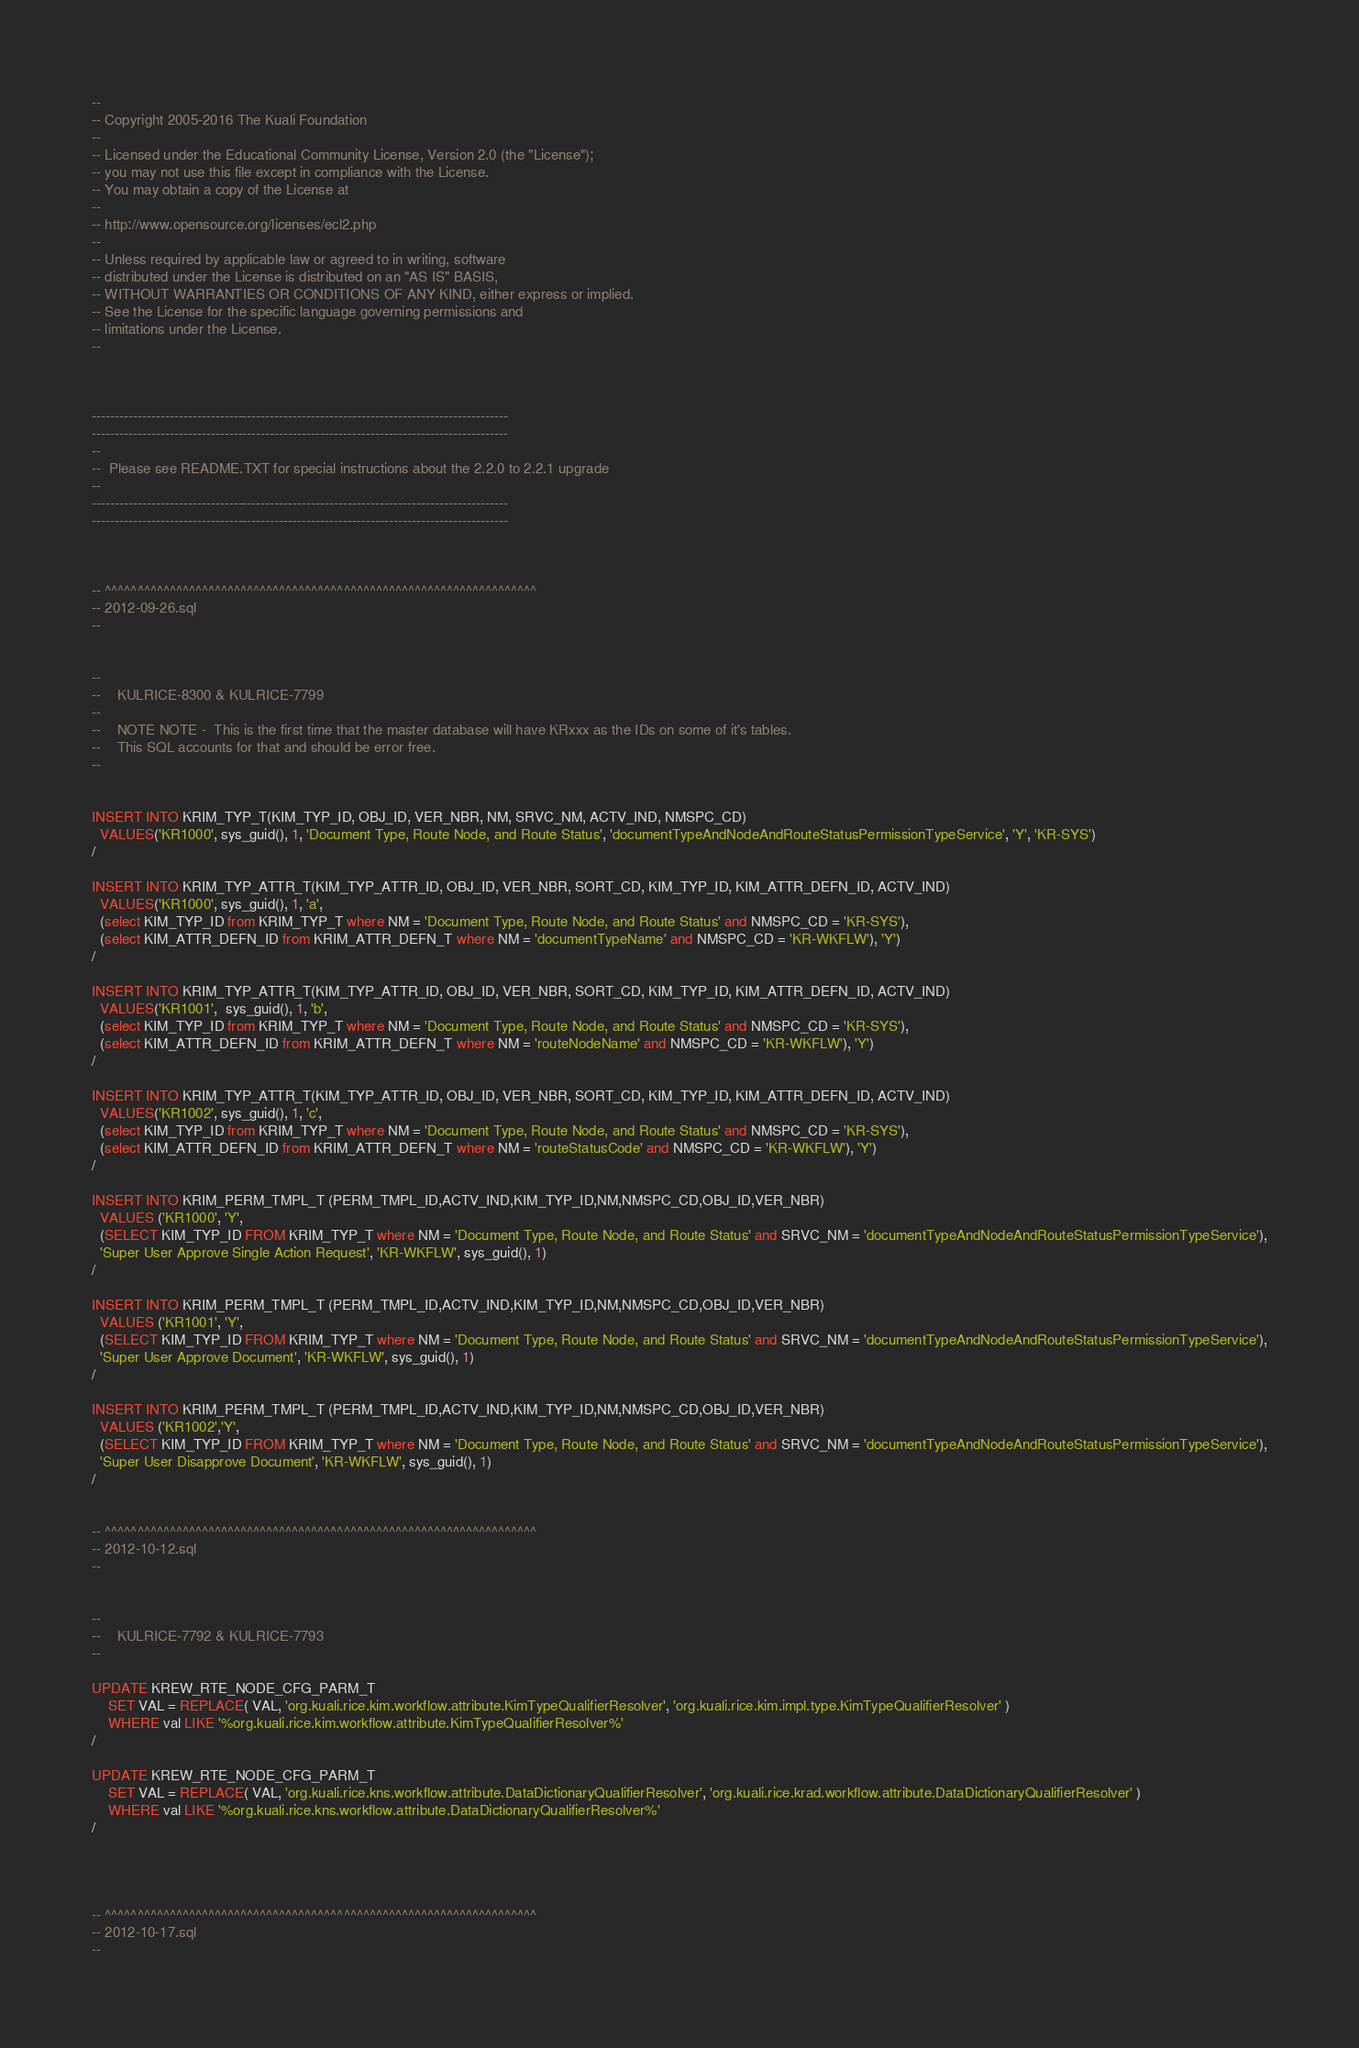<code> <loc_0><loc_0><loc_500><loc_500><_SQL_>--
-- Copyright 2005-2016 The Kuali Foundation
--
-- Licensed under the Educational Community License, Version 2.0 (the "License");
-- you may not use this file except in compliance with the License.
-- You may obtain a copy of the License at
--
-- http://www.opensource.org/licenses/ecl2.php
--
-- Unless required by applicable law or agreed to in writing, software
-- distributed under the License is distributed on an "AS IS" BASIS,
-- WITHOUT WARRANTIES OR CONDITIONS OF ANY KIND, either express or implied.
-- See the License for the specific language governing permissions and
-- limitations under the License.
--



-------------------------------------------------------------------------------------------
-------------------------------------------------------------------------------------------
--
--  Please see README.TXT for special instructions about the 2.2.0 to 2.2.1 upgrade
--
-------------------------------------------------------------------------------------------
-------------------------------------------------------------------------------------------



-- ^^^^^^^^^^^^^^^^^^^^^^^^^^^^^^^^^^^^^^^^^^^^^^^^^^^^^^^^^^^^^^^^^^^
-- 2012-09-26.sql
--


--
--    KULRICE-8300 & KULRICE-7799
--
--    NOTE NOTE -  This is the first time that the master database will have KRxxx as the IDs on some of it's tables.
--    This SQL accounts for that and should be error free.
--


INSERT INTO KRIM_TYP_T(KIM_TYP_ID, OBJ_ID, VER_NBR, NM, SRVC_NM, ACTV_IND, NMSPC_CD)
  VALUES('KR1000', sys_guid(), 1, 'Document Type, Route Node, and Route Status', 'documentTypeAndNodeAndRouteStatusPermissionTypeService', 'Y', 'KR-SYS')
/

INSERT INTO KRIM_TYP_ATTR_T(KIM_TYP_ATTR_ID, OBJ_ID, VER_NBR, SORT_CD, KIM_TYP_ID, KIM_ATTR_DEFN_ID, ACTV_IND)
  VALUES('KR1000', sys_guid(), 1, 'a',
  (select KIM_TYP_ID from KRIM_TYP_T where NM = 'Document Type, Route Node, and Route Status' and NMSPC_CD = 'KR-SYS'),
  (select KIM_ATTR_DEFN_ID from KRIM_ATTR_DEFN_T where NM = 'documentTypeName' and NMSPC_CD = 'KR-WKFLW'), 'Y')
/

INSERT INTO KRIM_TYP_ATTR_T(KIM_TYP_ATTR_ID, OBJ_ID, VER_NBR, SORT_CD, KIM_TYP_ID, KIM_ATTR_DEFN_ID, ACTV_IND)
  VALUES('KR1001',  sys_guid(), 1, 'b',
  (select KIM_TYP_ID from KRIM_TYP_T where NM = 'Document Type, Route Node, and Route Status' and NMSPC_CD = 'KR-SYS'),
  (select KIM_ATTR_DEFN_ID from KRIM_ATTR_DEFN_T where NM = 'routeNodeName' and NMSPC_CD = 'KR-WKFLW'), 'Y')
/

INSERT INTO KRIM_TYP_ATTR_T(KIM_TYP_ATTR_ID, OBJ_ID, VER_NBR, SORT_CD, KIM_TYP_ID, KIM_ATTR_DEFN_ID, ACTV_IND)
  VALUES('KR1002', sys_guid(), 1, 'c',
  (select KIM_TYP_ID from KRIM_TYP_T where NM = 'Document Type, Route Node, and Route Status' and NMSPC_CD = 'KR-SYS'),
  (select KIM_ATTR_DEFN_ID from KRIM_ATTR_DEFN_T where NM = 'routeStatusCode' and NMSPC_CD = 'KR-WKFLW'), 'Y')
/

INSERT INTO KRIM_PERM_TMPL_T (PERM_TMPL_ID,ACTV_IND,KIM_TYP_ID,NM,NMSPC_CD,OBJ_ID,VER_NBR)
  VALUES ('KR1000', 'Y',
  (SELECT KIM_TYP_ID FROM KRIM_TYP_T where NM = 'Document Type, Route Node, and Route Status' and SRVC_NM = 'documentTypeAndNodeAndRouteStatusPermissionTypeService'),
  'Super User Approve Single Action Request', 'KR-WKFLW', sys_guid(), 1)
/

INSERT INTO KRIM_PERM_TMPL_T (PERM_TMPL_ID,ACTV_IND,KIM_TYP_ID,NM,NMSPC_CD,OBJ_ID,VER_NBR)
  VALUES ('KR1001', 'Y',
  (SELECT KIM_TYP_ID FROM KRIM_TYP_T where NM = 'Document Type, Route Node, and Route Status' and SRVC_NM = 'documentTypeAndNodeAndRouteStatusPermissionTypeService'),
  'Super User Approve Document', 'KR-WKFLW', sys_guid(), 1)
/

INSERT INTO KRIM_PERM_TMPL_T (PERM_TMPL_ID,ACTV_IND,KIM_TYP_ID,NM,NMSPC_CD,OBJ_ID,VER_NBR)
  VALUES ('KR1002','Y',
  (SELECT KIM_TYP_ID FROM KRIM_TYP_T where NM = 'Document Type, Route Node, and Route Status' and SRVC_NM = 'documentTypeAndNodeAndRouteStatusPermissionTypeService'),
  'Super User Disapprove Document', 'KR-WKFLW', sys_guid(), 1)
/


-- ^^^^^^^^^^^^^^^^^^^^^^^^^^^^^^^^^^^^^^^^^^^^^^^^^^^^^^^^^^^^^^^^^^^
-- 2012-10-12.sql
--


--
--    KULRICE-7792 & KULRICE-7793
--

UPDATE KREW_RTE_NODE_CFG_PARM_T
    SET VAL = REPLACE( VAL, 'org.kuali.rice.kim.workflow.attribute.KimTypeQualifierResolver', 'org.kuali.rice.kim.impl.type.KimTypeQualifierResolver' )
    WHERE val LIKE '%org.kuali.rice.kim.workflow.attribute.KimTypeQualifierResolver%'
/

UPDATE KREW_RTE_NODE_CFG_PARM_T
    SET VAL = REPLACE( VAL, 'org.kuali.rice.kns.workflow.attribute.DataDictionaryQualifierResolver', 'org.kuali.rice.krad.workflow.attribute.DataDictionaryQualifierResolver' )
    WHERE val LIKE '%org.kuali.rice.kns.workflow.attribute.DataDictionaryQualifierResolver%'
/




-- ^^^^^^^^^^^^^^^^^^^^^^^^^^^^^^^^^^^^^^^^^^^^^^^^^^^^^^^^^^^^^^^^^^^
-- 2012-10-17.sql
--

</code> 